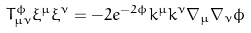Convert formula to latex. <formula><loc_0><loc_0><loc_500><loc_500>T _ { \mu \nu } ^ { \phi } \xi ^ { \mu } \xi ^ { \nu } = - 2 e ^ { - 2 \phi } k ^ { \mu } k ^ { \nu } \nabla _ { \mu } \nabla _ { \nu } \phi</formula> 